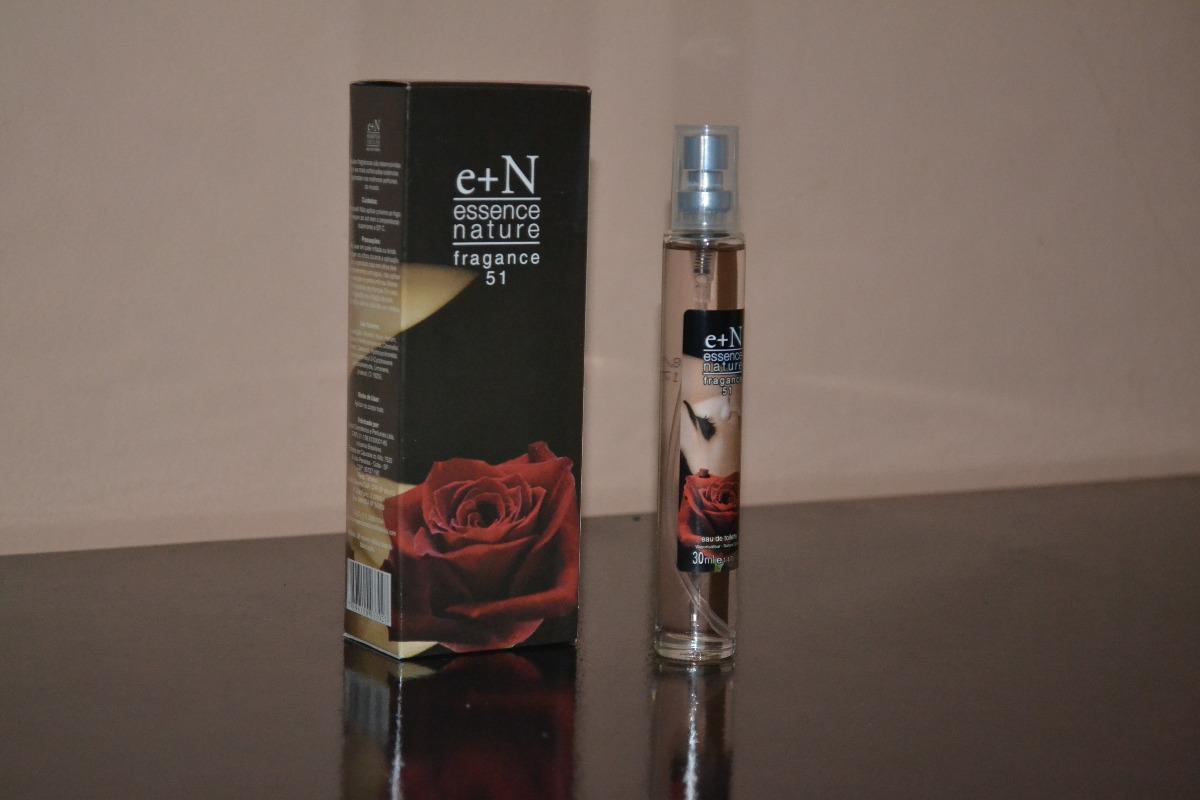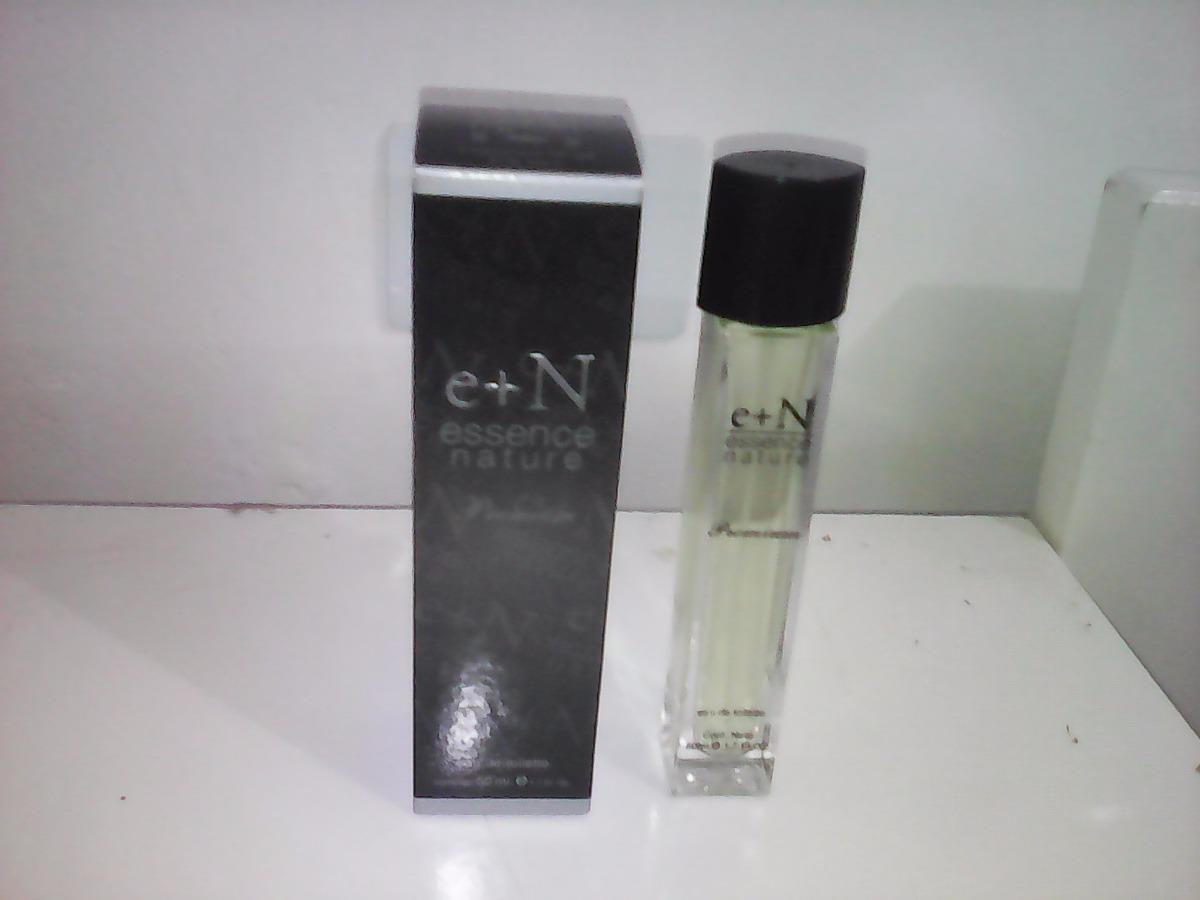The first image is the image on the left, the second image is the image on the right. Evaluate the accuracy of this statement regarding the images: "A pink perfume bottle is next to its box in the left image.". Is it true? Answer yes or no. No. The first image is the image on the left, the second image is the image on the right. For the images shown, is this caption "An image shows a product with a galloping horse on the front of the package." true? Answer yes or no. No. 